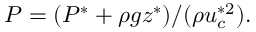Convert formula to latex. <formula><loc_0><loc_0><loc_500><loc_500>P = ( P ^ { * } + \rho g z ^ { * } ) / ( \rho u _ { c } ^ { * 2 } ) .</formula> 